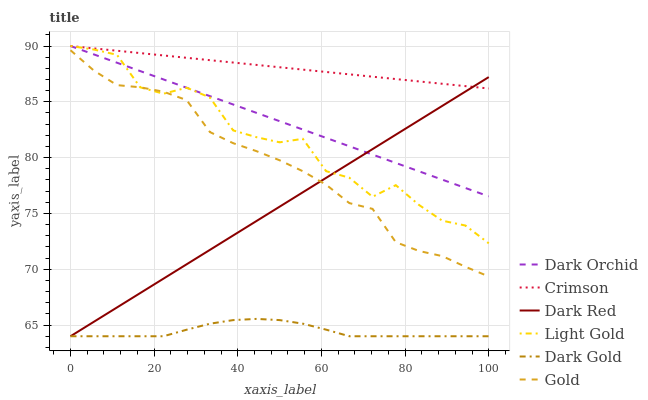Does Dark Gold have the minimum area under the curve?
Answer yes or no. Yes. Does Crimson have the maximum area under the curve?
Answer yes or no. Yes. Does Dark Red have the minimum area under the curve?
Answer yes or no. No. Does Dark Red have the maximum area under the curve?
Answer yes or no. No. Is Dark Orchid the smoothest?
Answer yes or no. Yes. Is Light Gold the roughest?
Answer yes or no. Yes. Is Dark Gold the smoothest?
Answer yes or no. No. Is Dark Gold the roughest?
Answer yes or no. No. Does Dark Orchid have the lowest value?
Answer yes or no. No. Does Dark Red have the highest value?
Answer yes or no. No. Is Dark Gold less than Light Gold?
Answer yes or no. Yes. Is Crimson greater than Gold?
Answer yes or no. Yes. Does Dark Gold intersect Light Gold?
Answer yes or no. No. 